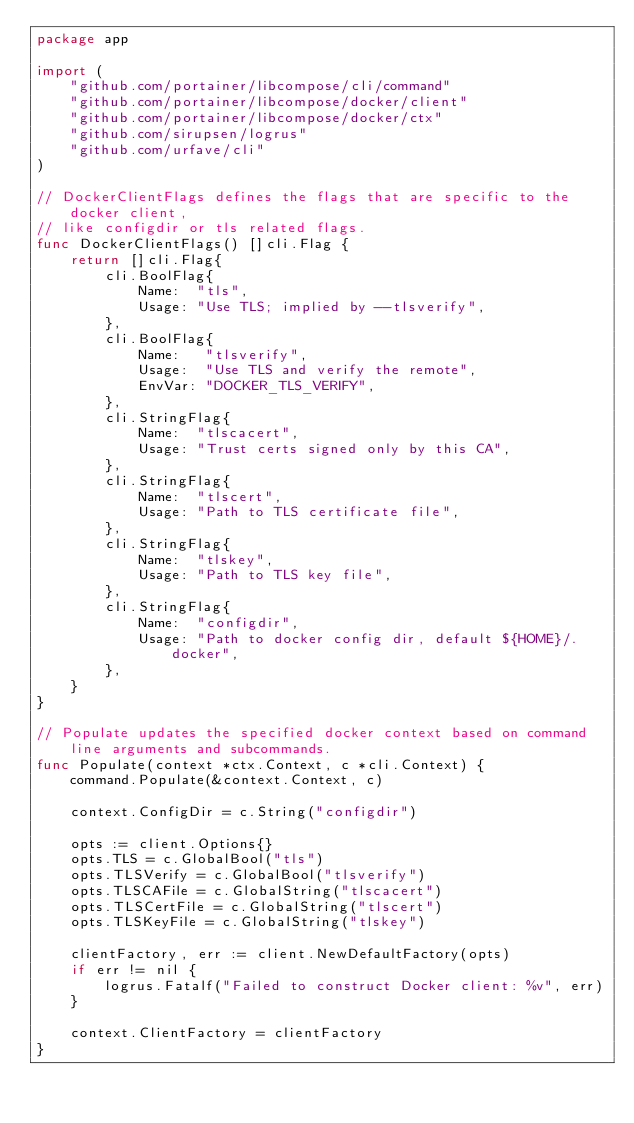Convert code to text. <code><loc_0><loc_0><loc_500><loc_500><_Go_>package app

import (
	"github.com/portainer/libcompose/cli/command"
	"github.com/portainer/libcompose/docker/client"
	"github.com/portainer/libcompose/docker/ctx"
	"github.com/sirupsen/logrus"
	"github.com/urfave/cli"
)

// DockerClientFlags defines the flags that are specific to the docker client,
// like configdir or tls related flags.
func DockerClientFlags() []cli.Flag {
	return []cli.Flag{
		cli.BoolFlag{
			Name:  "tls",
			Usage: "Use TLS; implied by --tlsverify",
		},
		cli.BoolFlag{
			Name:   "tlsverify",
			Usage:  "Use TLS and verify the remote",
			EnvVar: "DOCKER_TLS_VERIFY",
		},
		cli.StringFlag{
			Name:  "tlscacert",
			Usage: "Trust certs signed only by this CA",
		},
		cli.StringFlag{
			Name:  "tlscert",
			Usage: "Path to TLS certificate file",
		},
		cli.StringFlag{
			Name:  "tlskey",
			Usage: "Path to TLS key file",
		},
		cli.StringFlag{
			Name:  "configdir",
			Usage: "Path to docker config dir, default ${HOME}/.docker",
		},
	}
}

// Populate updates the specified docker context based on command line arguments and subcommands.
func Populate(context *ctx.Context, c *cli.Context) {
	command.Populate(&context.Context, c)

	context.ConfigDir = c.String("configdir")

	opts := client.Options{}
	opts.TLS = c.GlobalBool("tls")
	opts.TLSVerify = c.GlobalBool("tlsverify")
	opts.TLSCAFile = c.GlobalString("tlscacert")
	opts.TLSCertFile = c.GlobalString("tlscert")
	opts.TLSKeyFile = c.GlobalString("tlskey")

	clientFactory, err := client.NewDefaultFactory(opts)
	if err != nil {
		logrus.Fatalf("Failed to construct Docker client: %v", err)
	}

	context.ClientFactory = clientFactory
}
</code> 